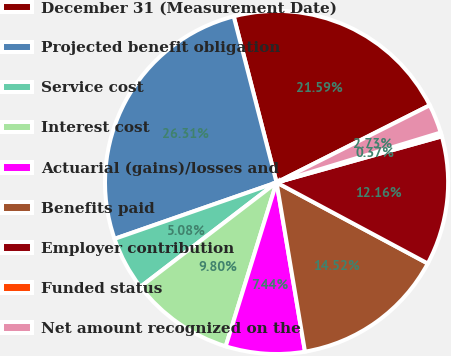<chart> <loc_0><loc_0><loc_500><loc_500><pie_chart><fcel>December 31 (Measurement Date)<fcel>Projected benefit obligation<fcel>Service cost<fcel>Interest cost<fcel>Actuarial (gains)/losses and<fcel>Benefits paid<fcel>Employer contribution<fcel>Funded status<fcel>Net amount recognized on the<nl><fcel>21.59%<fcel>26.31%<fcel>5.08%<fcel>9.8%<fcel>7.44%<fcel>14.52%<fcel>12.16%<fcel>0.37%<fcel>2.73%<nl></chart> 